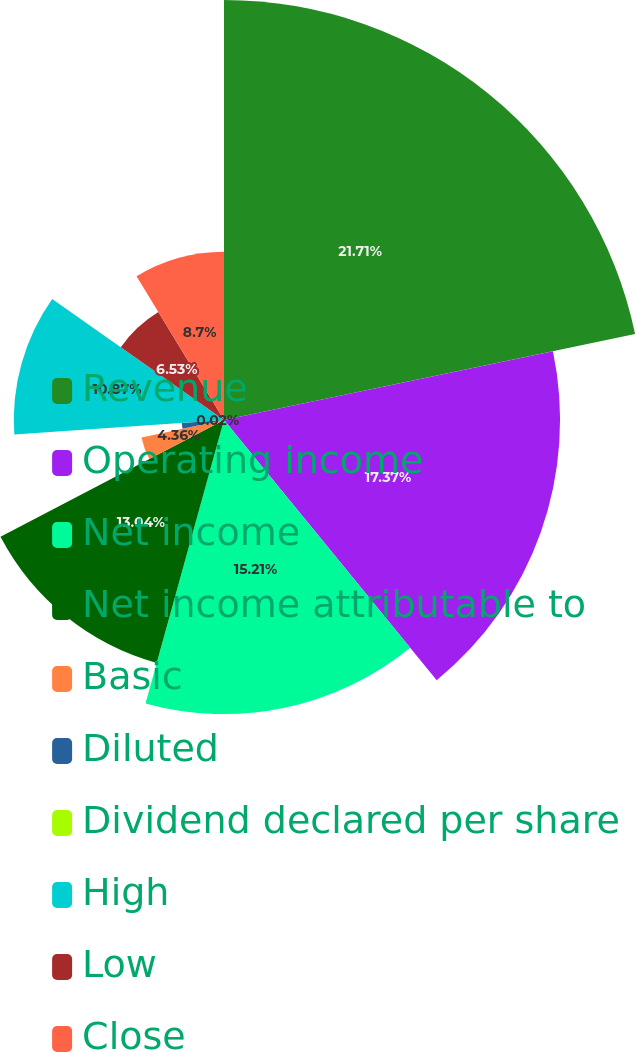Convert chart. <chart><loc_0><loc_0><loc_500><loc_500><pie_chart><fcel>Revenue<fcel>Operating income<fcel>Net income<fcel>Net income attributable to<fcel>Basic<fcel>Diluted<fcel>Dividend declared per share<fcel>High<fcel>Low<fcel>Close<nl><fcel>21.72%<fcel>17.38%<fcel>15.21%<fcel>13.04%<fcel>4.36%<fcel>2.19%<fcel>0.02%<fcel>10.87%<fcel>6.53%<fcel>8.7%<nl></chart> 